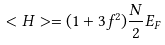<formula> <loc_0><loc_0><loc_500><loc_500>< H > = ( 1 + 3 f ^ { 2 } ) \frac { N } { 2 } E _ { F }</formula> 